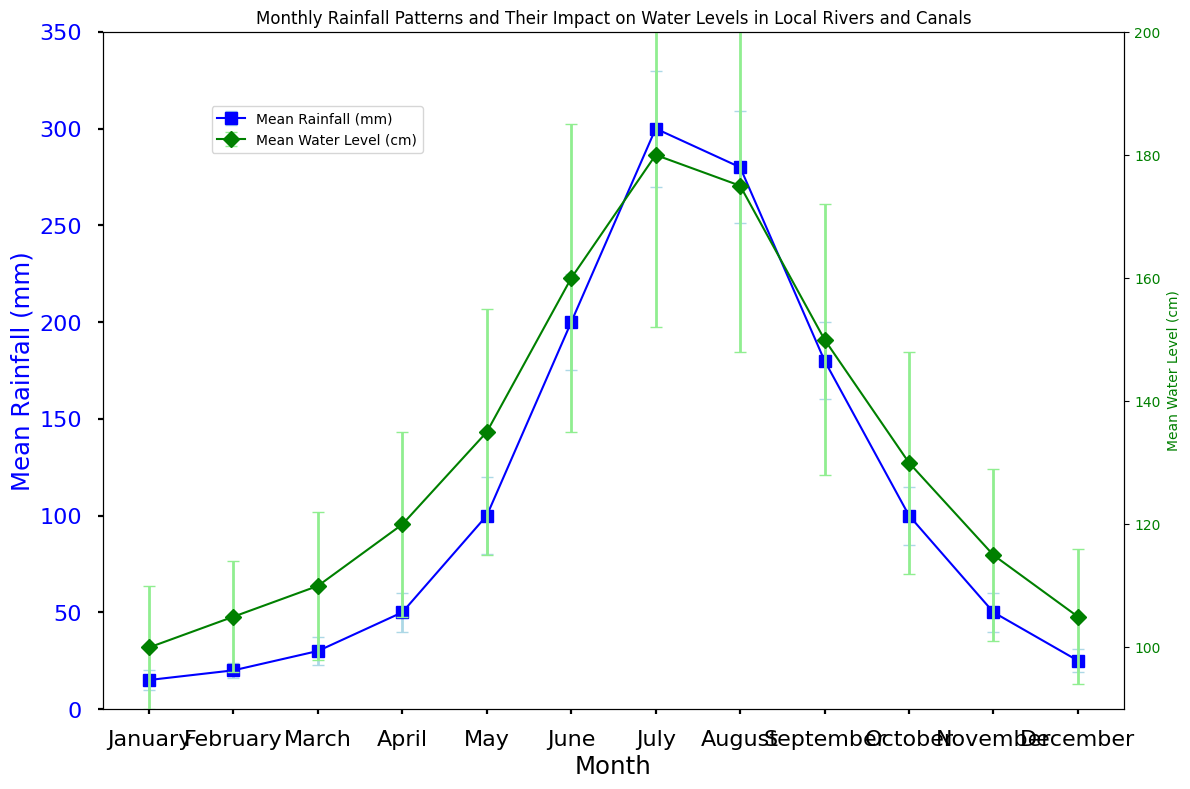What is the month with the highest mean rainfall? The blue line represents the mean rainfall. By locating the highest point, we find July has the highest mean rainfall.
Answer: July What is the difference in the mean water level between June and December? The green line represents the mean water level. June's mean water level is 160 cm, and December's mean water level is 105 cm. The difference is 160 - 105.
Answer: 55 cm How does the mean water level change from January to August? By following the green line and points from January to August, we see that the mean water level increases from 100 cm in January to 175 cm in August.
Answer: Increase In which month is the standard deviation of rainfall the highest? The error bars represent the standard deviation. The month with the tallest blue error bar is July, indicating the highest standard deviation of rainfall.
Answer: July Compare the mean water levels in May and September. Which month has a higher mean water level? The green markers show that May's mean water level is 135 cm and September's is 150 cm. September has a higher mean water level than May.
Answer: September What is the average mean rainfall for the months of March, April, and May? The mean rainfalls are 30 mm for March, 50 mm for April, and 100 mm for May. The average is (30 + 50 + 100) / 3.
Answer: 60 mm During which months does the mean rainfall exceed 200 mm? Looking at the blue markers, the mean rainfall exceeds 200 mm in June, July, and August.
Answer: June, July, August What is the combined standard deviation for rainfall in June and July? The standard deviation for rainfall is 25 mm in June and 30 mm in July. Their combined total is 25 + 30.
Answer: 55 mm Which month shows the least change in water level compared to its rainfall standard deviation? Comparison requires reviewing the relative heights of green error bars (water level deviation) to blue error bars (rainfall deviation). February has smaller deviations for both metrics.
Answer: February 